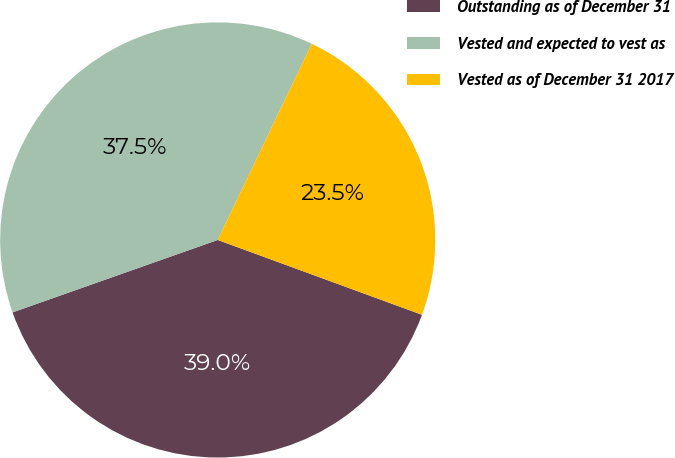Convert chart. <chart><loc_0><loc_0><loc_500><loc_500><pie_chart><fcel>Outstanding as of December 31<fcel>Vested and expected to vest as<fcel>Vested as of December 31 2017<nl><fcel>39.01%<fcel>37.52%<fcel>23.47%<nl></chart> 